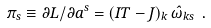Convert formula to latex. <formula><loc_0><loc_0><loc_500><loc_500>\pi _ { s } \equiv \partial L / \partial \dot { a } ^ { s } = ( I T - J ) _ { k } \, \hat { \omega } _ { k s } \ .</formula> 